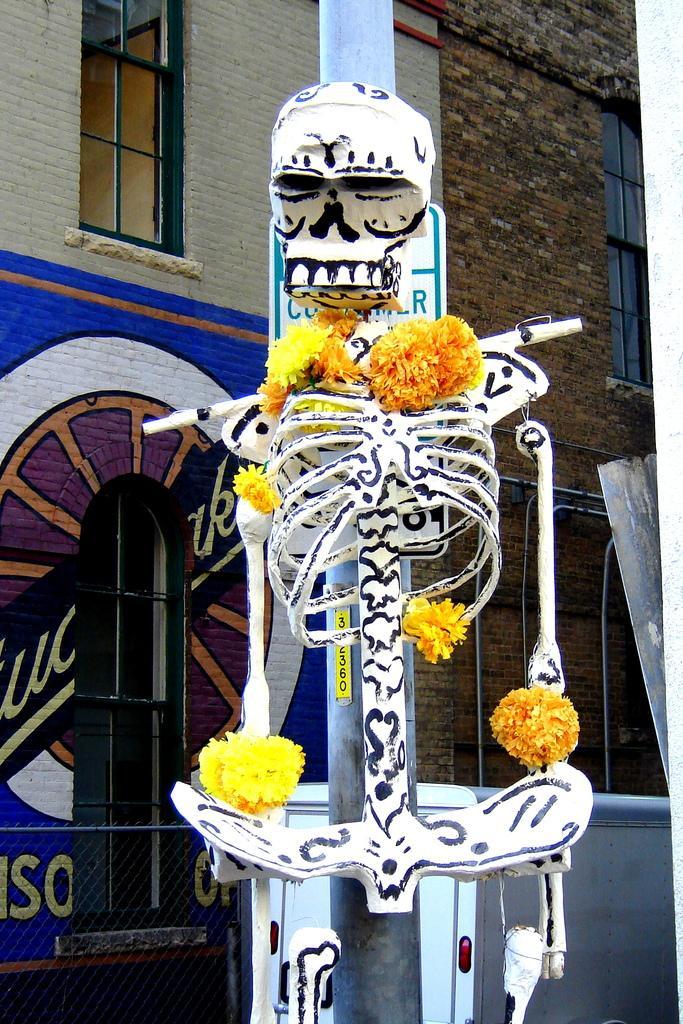How would you summarize this image in a sentence or two? In this picture we can see a skeleton with flowers and in the background we can see a building with windows and pole. 